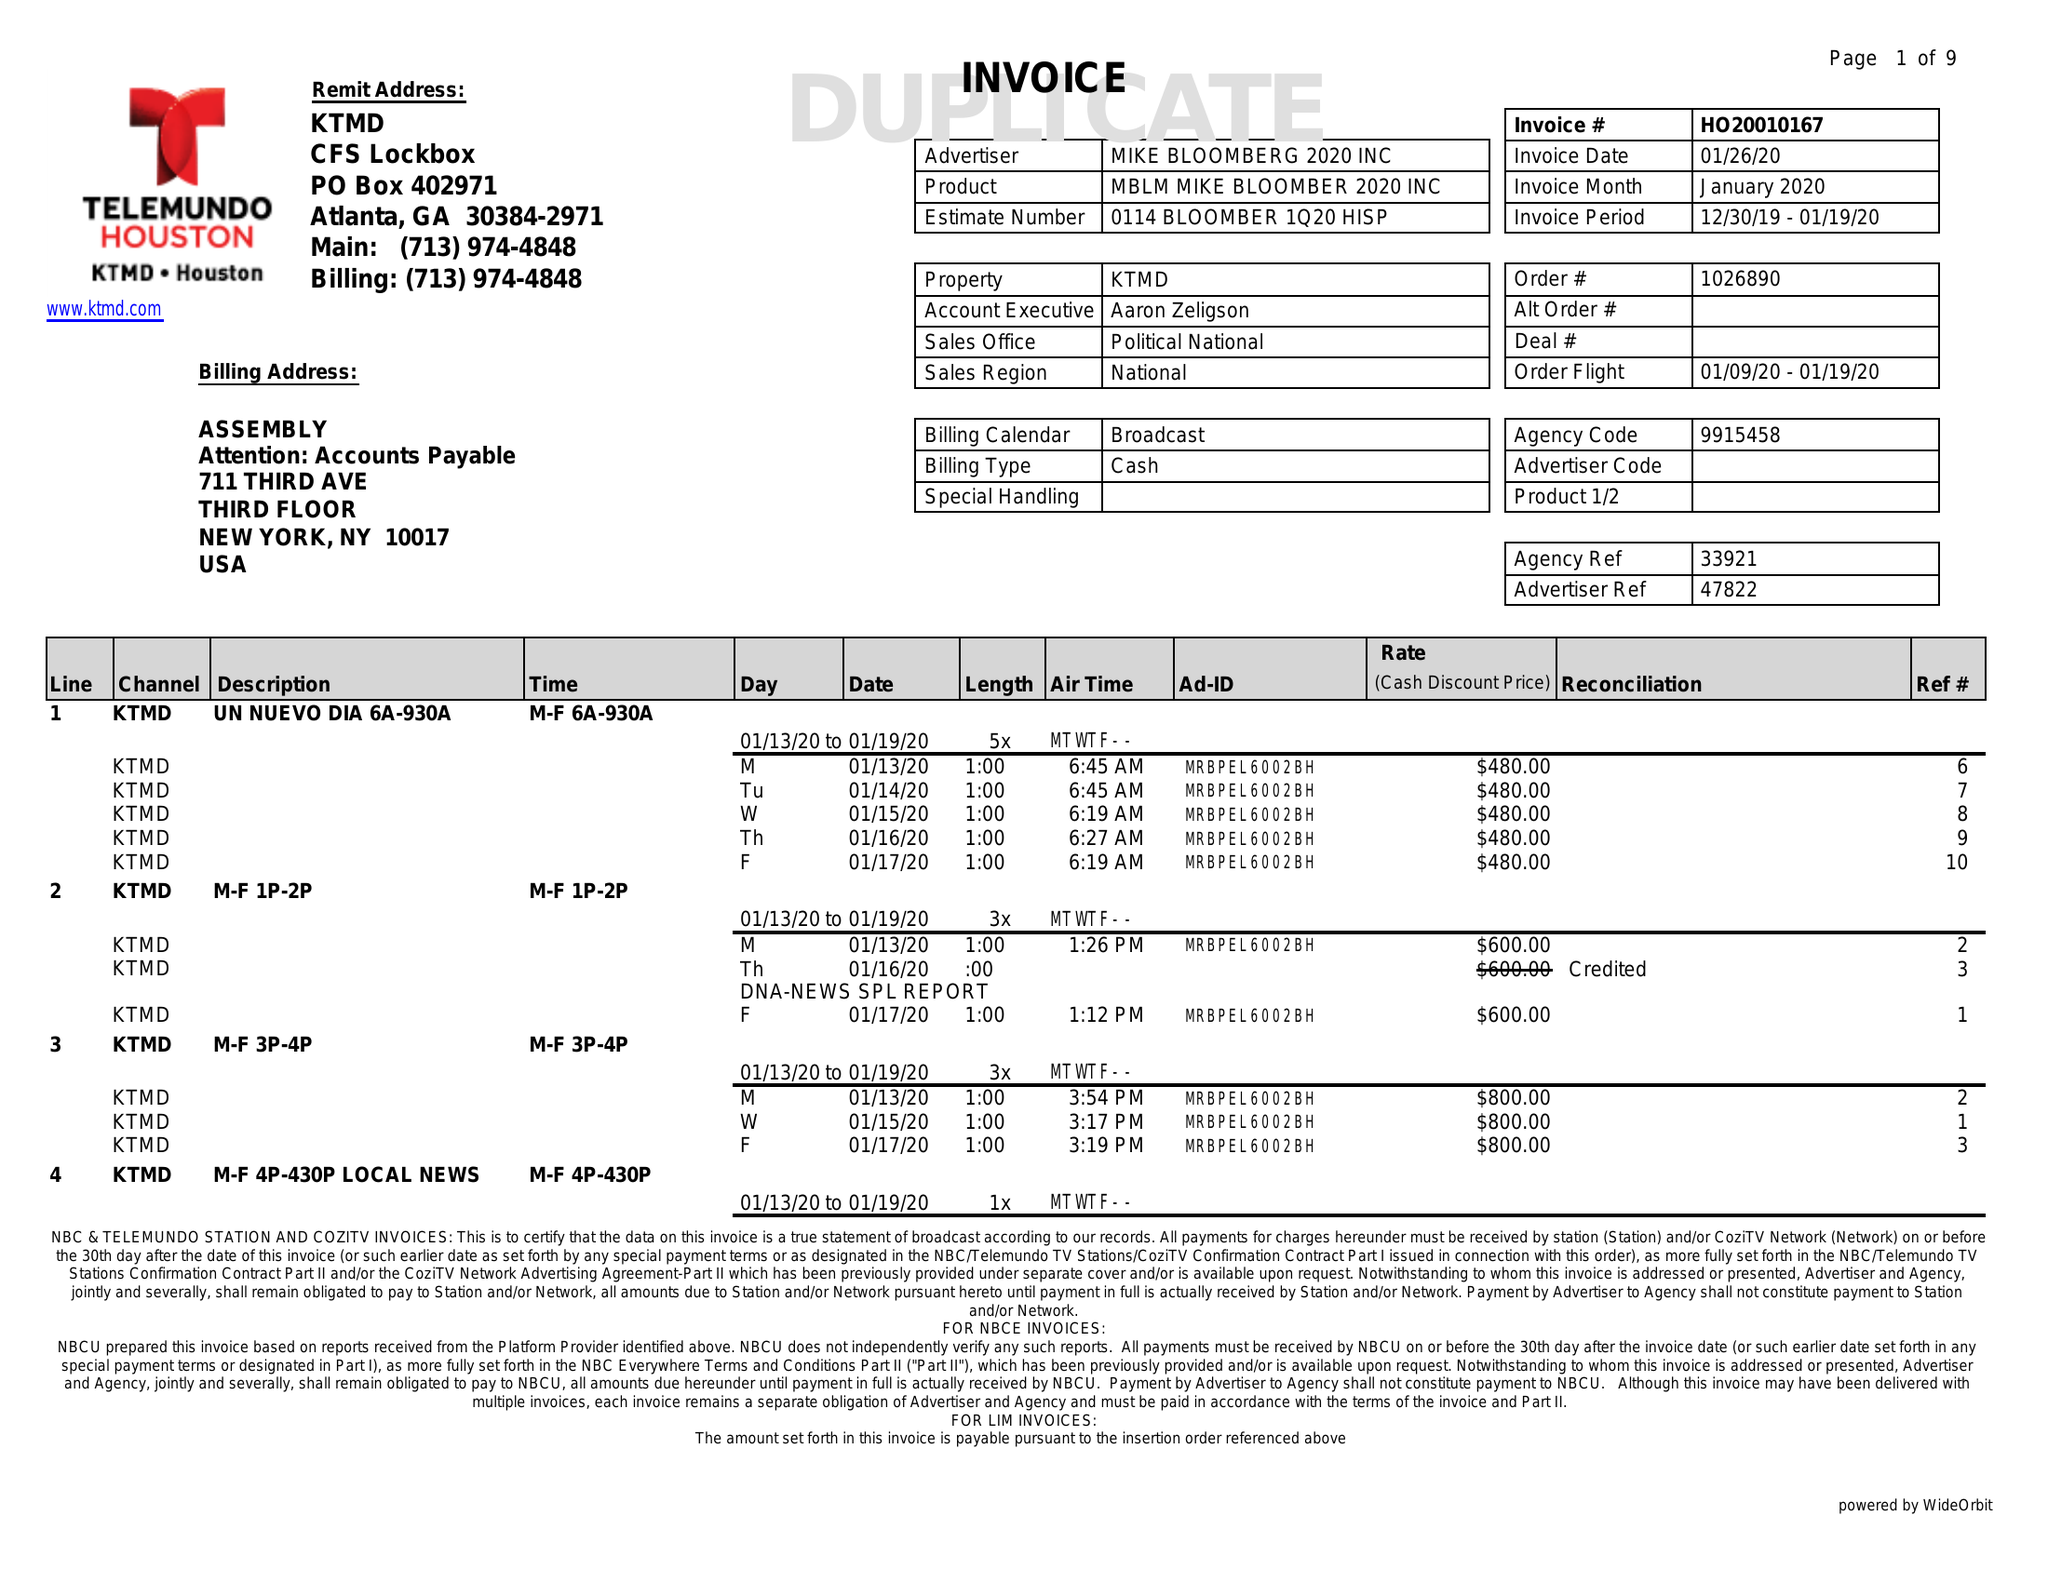What is the value for the advertiser?
Answer the question using a single word or phrase. MIKE BLOOMBERG 2020 INC 